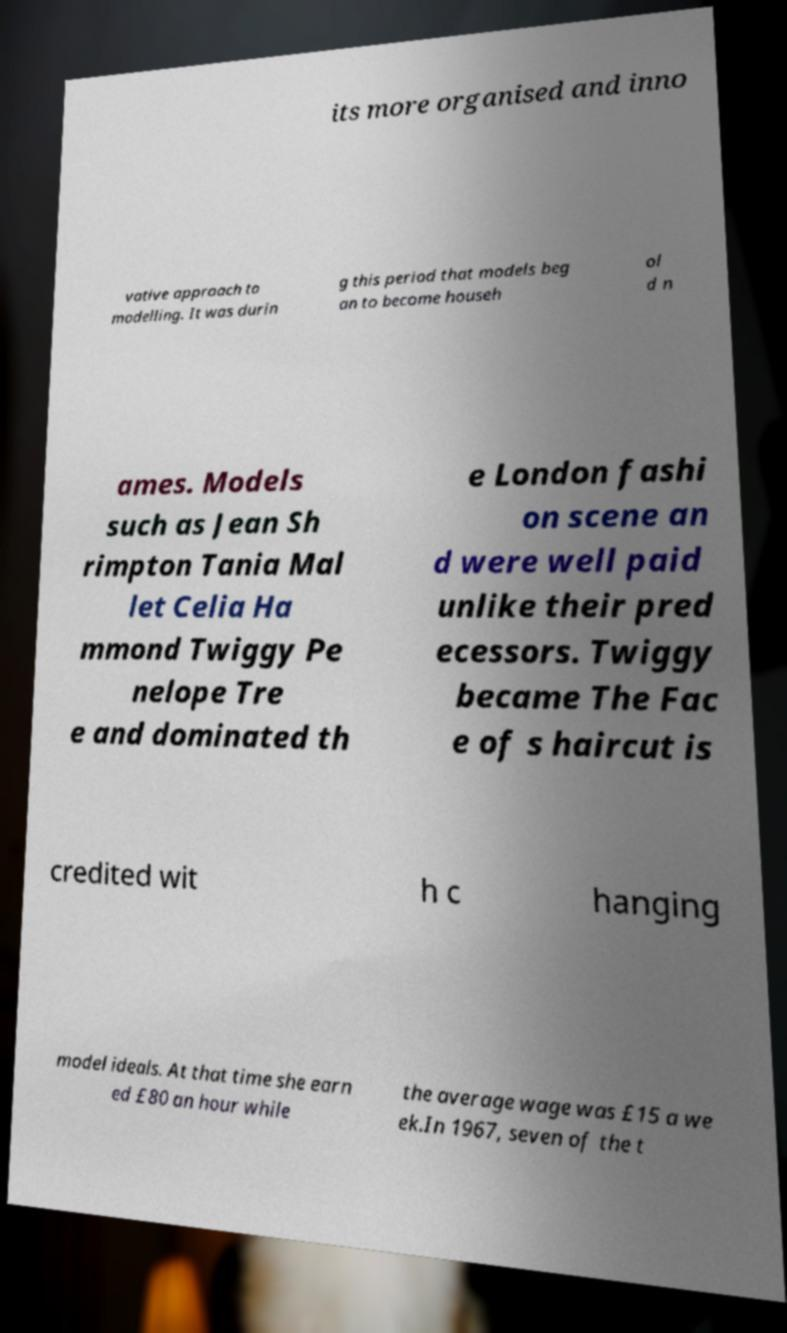I need the written content from this picture converted into text. Can you do that? its more organised and inno vative approach to modelling. It was durin g this period that models beg an to become househ ol d n ames. Models such as Jean Sh rimpton Tania Mal let Celia Ha mmond Twiggy Pe nelope Tre e and dominated th e London fashi on scene an d were well paid unlike their pred ecessors. Twiggy became The Fac e of s haircut is credited wit h c hanging model ideals. At that time she earn ed £80 an hour while the average wage was £15 a we ek.In 1967, seven of the t 